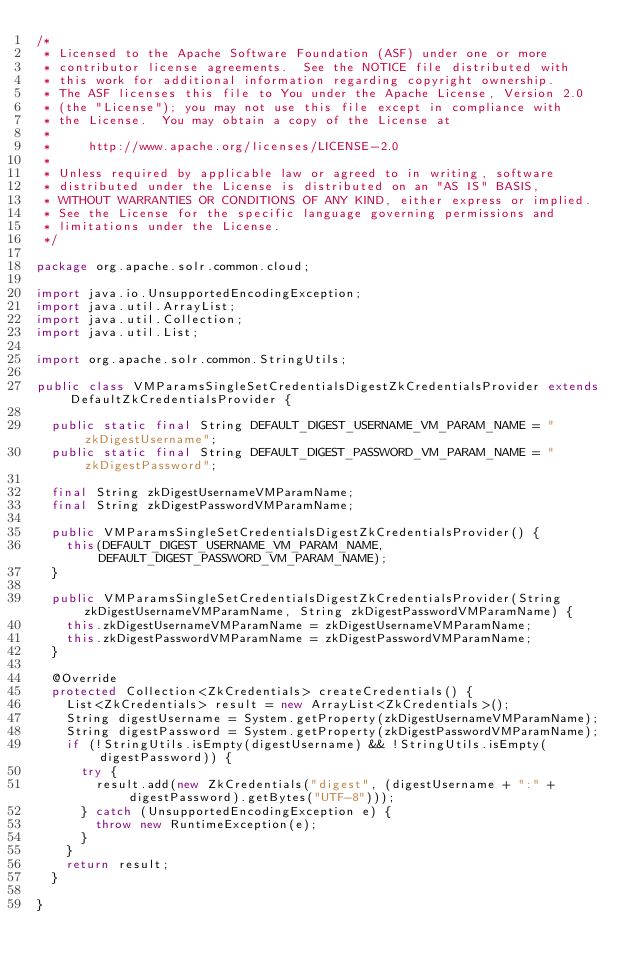Convert code to text. <code><loc_0><loc_0><loc_500><loc_500><_Java_>/*
 * Licensed to the Apache Software Foundation (ASF) under one or more
 * contributor license agreements.  See the NOTICE file distributed with
 * this work for additional information regarding copyright ownership.
 * The ASF licenses this file to You under the Apache License, Version 2.0
 * (the "License"); you may not use this file except in compliance with
 * the License.  You may obtain a copy of the License at
 *
 *     http://www.apache.org/licenses/LICENSE-2.0
 *
 * Unless required by applicable law or agreed to in writing, software
 * distributed under the License is distributed on an "AS IS" BASIS,
 * WITHOUT WARRANTIES OR CONDITIONS OF ANY KIND, either express or implied.
 * See the License for the specific language governing permissions and
 * limitations under the License.
 */

package org.apache.solr.common.cloud;

import java.io.UnsupportedEncodingException;
import java.util.ArrayList;
import java.util.Collection;
import java.util.List;

import org.apache.solr.common.StringUtils;

public class VMParamsSingleSetCredentialsDigestZkCredentialsProvider extends DefaultZkCredentialsProvider {
  
  public static final String DEFAULT_DIGEST_USERNAME_VM_PARAM_NAME = "zkDigestUsername";
  public static final String DEFAULT_DIGEST_PASSWORD_VM_PARAM_NAME = "zkDigestPassword";
  
  final String zkDigestUsernameVMParamName;
  final String zkDigestPasswordVMParamName;
  
  public VMParamsSingleSetCredentialsDigestZkCredentialsProvider() {
    this(DEFAULT_DIGEST_USERNAME_VM_PARAM_NAME, DEFAULT_DIGEST_PASSWORD_VM_PARAM_NAME);
  }
  
  public VMParamsSingleSetCredentialsDigestZkCredentialsProvider(String zkDigestUsernameVMParamName, String zkDigestPasswordVMParamName) {
    this.zkDigestUsernameVMParamName = zkDigestUsernameVMParamName;
    this.zkDigestPasswordVMParamName = zkDigestPasswordVMParamName;
  }

  @Override
  protected Collection<ZkCredentials> createCredentials() {
    List<ZkCredentials> result = new ArrayList<ZkCredentials>();
    String digestUsername = System.getProperty(zkDigestUsernameVMParamName);
    String digestPassword = System.getProperty(zkDigestPasswordVMParamName);
    if (!StringUtils.isEmpty(digestUsername) && !StringUtils.isEmpty(digestPassword)) {
      try {
        result.add(new ZkCredentials("digest", (digestUsername + ":" + digestPassword).getBytes("UTF-8")));
      } catch (UnsupportedEncodingException e) {
        throw new RuntimeException(e);
      }
    }
    return result;
  }
  
}

</code> 